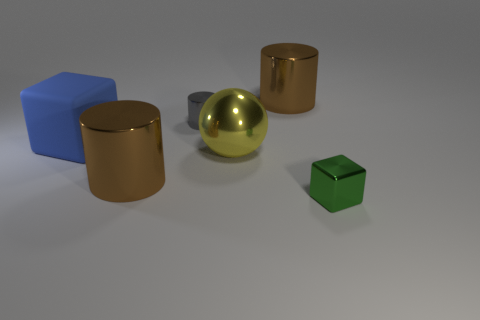Subtract all yellow cubes. Subtract all blue cylinders. How many cubes are left? 2 Add 2 tiny green shiny blocks. How many objects exist? 8 Subtract all balls. How many objects are left? 5 Add 1 small brown matte balls. How many small brown matte balls exist? 1 Subtract 0 red cylinders. How many objects are left? 6 Subtract all large purple metal spheres. Subtract all tiny green objects. How many objects are left? 5 Add 4 big blocks. How many big blocks are left? 5 